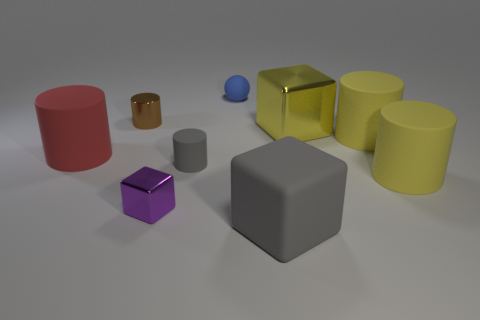There is a small thing that is the same color as the large rubber block; what shape is it?
Your answer should be compact. Cylinder. Are there any other things that have the same material as the large gray object?
Provide a short and direct response. Yes. Does the small gray object have the same material as the yellow block?
Give a very brief answer. No. There is a large thing on the left side of the big cube that is on the left side of the yellow block behind the tiny purple block; what is its shape?
Offer a very short reply. Cylinder. Is the number of yellow metallic cubes left of the blue sphere less than the number of red matte cylinders in front of the tiny brown thing?
Offer a very short reply. Yes. There is a gray object that is behind the small metal object in front of the brown metal thing; what is its shape?
Provide a short and direct response. Cylinder. Is there any other thing of the same color as the large rubber block?
Offer a terse response. Yes. Is the big metallic block the same color as the tiny ball?
Give a very brief answer. No. What number of yellow objects are balls or large matte cylinders?
Offer a very short reply. 2. Are there fewer gray matte objects behind the brown metal cylinder than small gray metal balls?
Provide a short and direct response. No. 